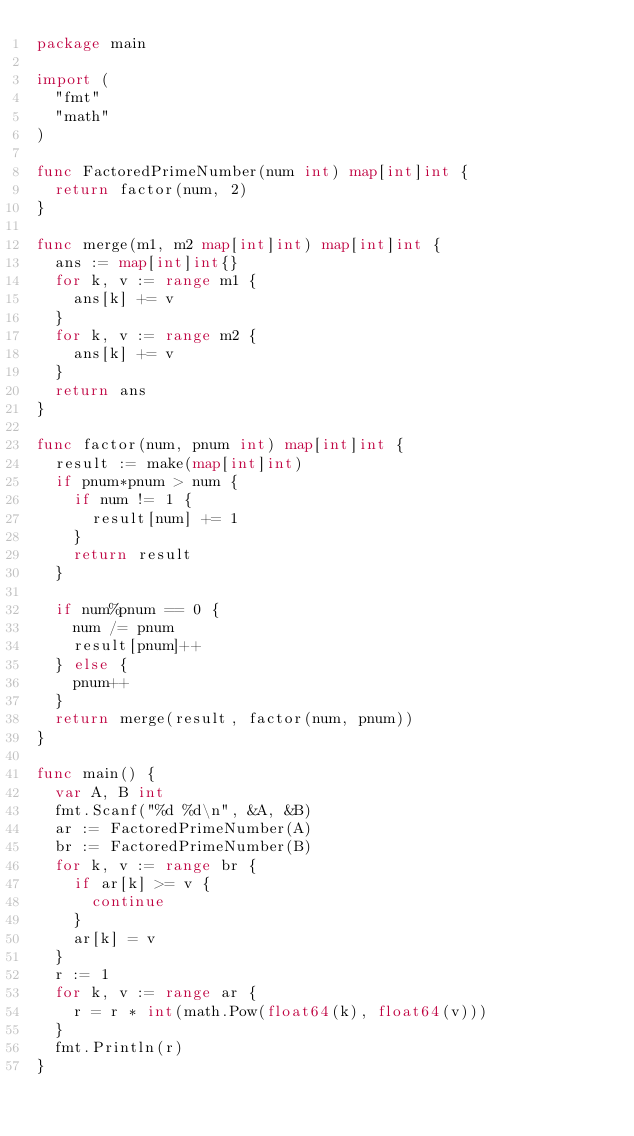<code> <loc_0><loc_0><loc_500><loc_500><_Go_>package main

import (
	"fmt"
	"math"
)

func FactoredPrimeNumber(num int) map[int]int {
	return factor(num, 2)
}

func merge(m1, m2 map[int]int) map[int]int {
	ans := map[int]int{}
	for k, v := range m1 {
		ans[k] += v
	}
	for k, v := range m2 {
		ans[k] += v
	}
	return ans
}

func factor(num, pnum int) map[int]int {
	result := make(map[int]int)
	if pnum*pnum > num {
		if num != 1 {
			result[num] += 1
		}
		return result
	}

	if num%pnum == 0 {
		num /= pnum
		result[pnum]++
	} else {
		pnum++
	}
	return merge(result, factor(num, pnum))
}

func main() {
	var A, B int
	fmt.Scanf("%d %d\n", &A, &B)
	ar := FactoredPrimeNumber(A)
	br := FactoredPrimeNumber(B)
	for k, v := range br {
		if ar[k] >= v {
			continue
		}
		ar[k] = v
	}
	r := 1
	for k, v := range ar {
		r = r * int(math.Pow(float64(k), float64(v)))
	}
	fmt.Println(r)
}
</code> 